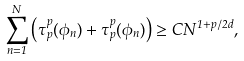<formula> <loc_0><loc_0><loc_500><loc_500>\sum _ { n = 1 } ^ { N } \left ( \tau _ { p } ^ { p } ( \phi _ { n } ) + \tau _ { p } ^ { p } ( \phi _ { n } ) \right ) \geq C N ^ { 1 + p / 2 d } ,</formula> 